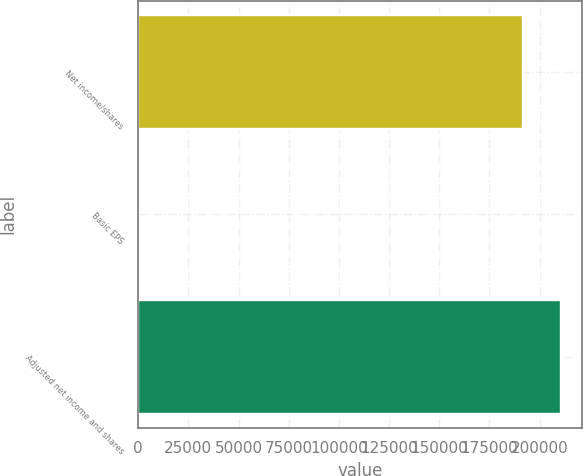Convert chart. <chart><loc_0><loc_0><loc_500><loc_500><bar_chart><fcel>Net income/shares<fcel>Basic EPS<fcel>Adjusted net income and shares<nl><fcel>191597<fcel>3.42<fcel>210756<nl></chart> 